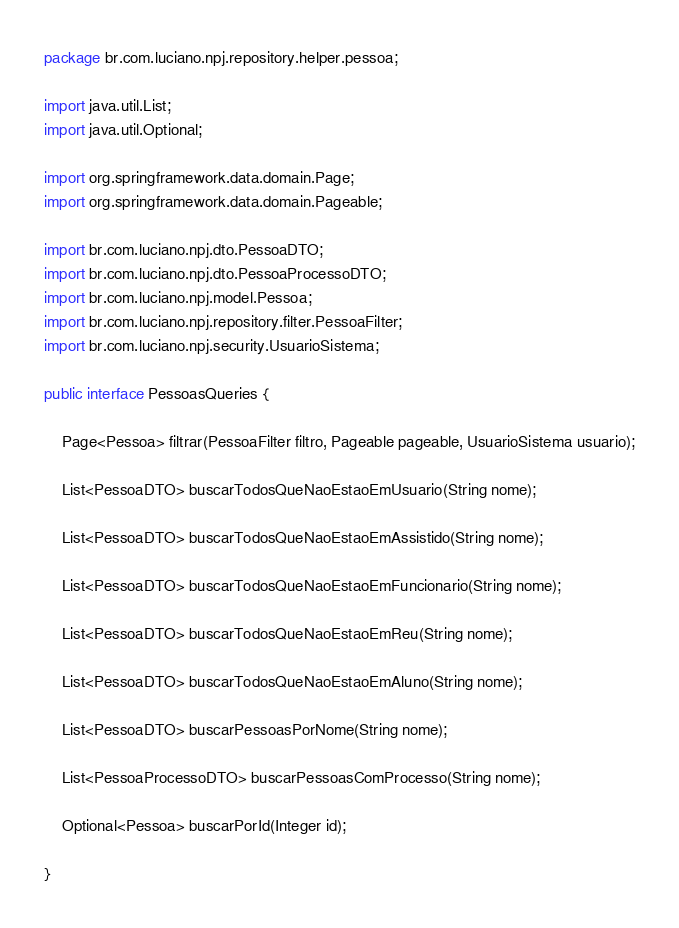<code> <loc_0><loc_0><loc_500><loc_500><_Java_>package br.com.luciano.npj.repository.helper.pessoa;

import java.util.List;
import java.util.Optional;

import org.springframework.data.domain.Page;
import org.springframework.data.domain.Pageable;

import br.com.luciano.npj.dto.PessoaDTO;
import br.com.luciano.npj.dto.PessoaProcessoDTO;
import br.com.luciano.npj.model.Pessoa;
import br.com.luciano.npj.repository.filter.PessoaFilter;
import br.com.luciano.npj.security.UsuarioSistema;

public interface PessoasQueries {
	
	Page<Pessoa> filtrar(PessoaFilter filtro, Pageable pageable, UsuarioSistema usuario);
	
	List<PessoaDTO> buscarTodosQueNaoEstaoEmUsuario(String nome);
	
	List<PessoaDTO> buscarTodosQueNaoEstaoEmAssistido(String nome);
	
	List<PessoaDTO> buscarTodosQueNaoEstaoEmFuncionario(String nome);
	
	List<PessoaDTO> buscarTodosQueNaoEstaoEmReu(String nome);
	
	List<PessoaDTO> buscarTodosQueNaoEstaoEmAluno(String nome);
	
	List<PessoaDTO> buscarPessoasPorNome(String nome);
	
	List<PessoaProcessoDTO> buscarPessoasComProcesso(String nome);
	
	Optional<Pessoa> buscarPorId(Integer id);

}
</code> 